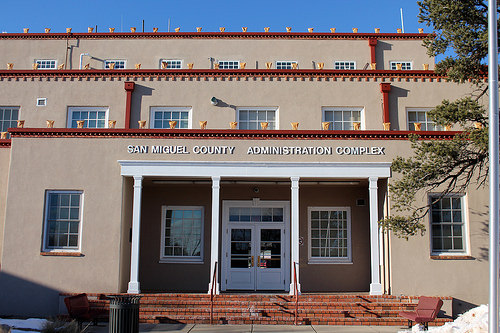<image>
Is the can next to the door? No. The can is not positioned next to the door. They are located in different areas of the scene. 